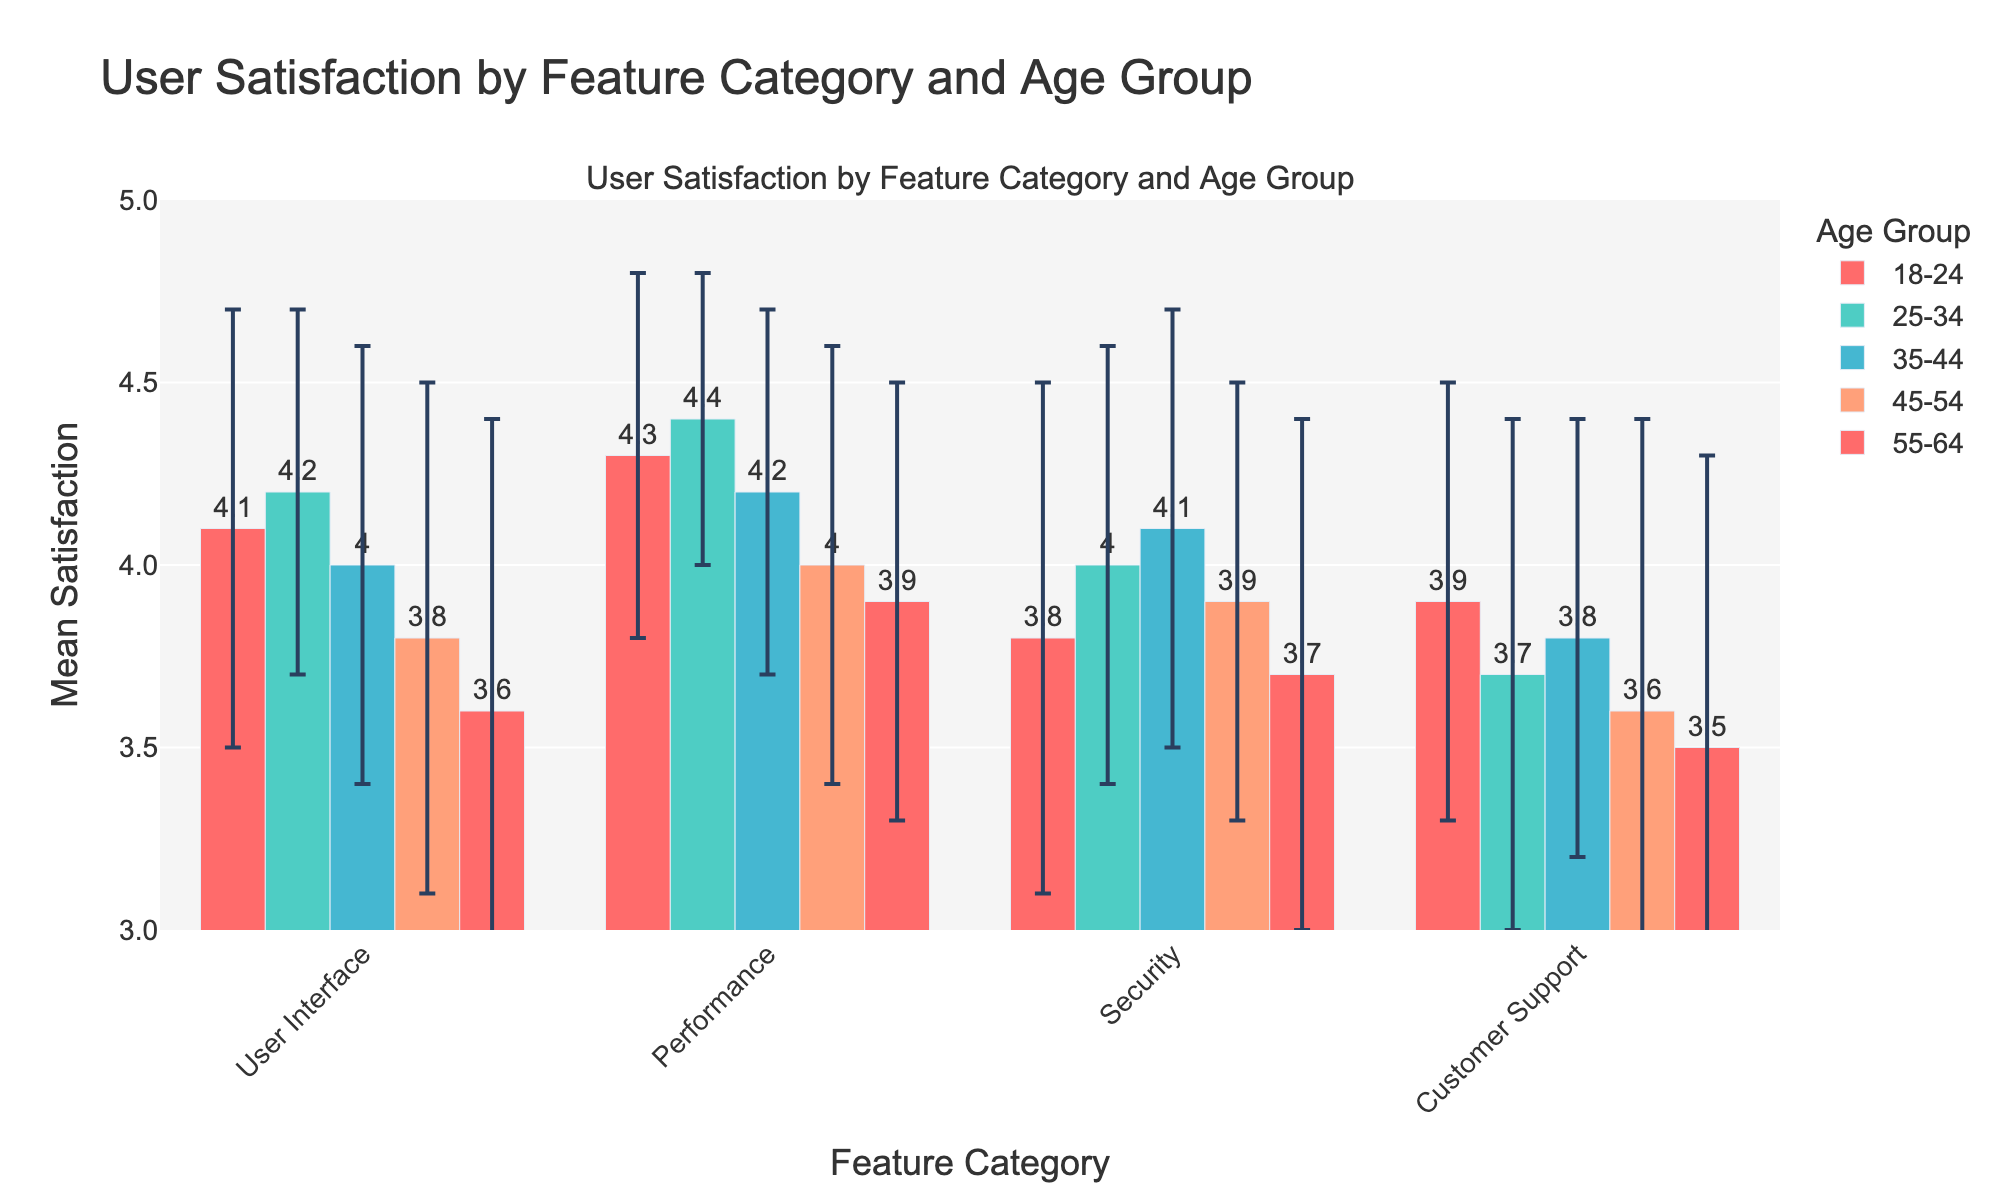What is the title of the figure? The title of the figure can be found at the top of the plot, which describes what the figure is about.
Answer: User Satisfaction by Feature Category and Age Group What feature category has the highest mean satisfaction rating for the age group 25-34? The bar representing the feature category with the highest value under the age group 25-34 will indicate the highest mean satisfaction rating.
Answer: Performance How does the mean satisfaction rating for Security in the age group 35-44 compare to the mean satisfaction rating for Security in the age group 18-24? Locate the bars representing the Security feature category for both age groups 18-24 and 35-44 and compare their heights.
Answer: Higher Which feature category has the largest variation in mean satisfaction ratings across all age groups? The feature category with the largest spread (or variation) among the mean satisfaction ratings across all age groups can be determined by observing the length of error bars.
Answer: Security What is the mean satisfaction rating for User Interface in the age group 55-64? Find the bar representing User Interface in the 55-64 age group and read off its value.
Answer: 3.6 What is the overall trend in mean satisfaction ratings for the Customer Support feature category as the age group increases from 18-24 to 55-64? By analyzing the heights of the bars for Customer Support across age groups 18-24, 25-34, 35-44, 45-54, and 55-64, the trend can be determined.
Answer: Decreasing What is the standard deviation for the age group 45-54 in the Performance feature category? Check the error bar length for the Performance bar within the 45-54 age group, which represents the standard deviation.
Answer: 0.6 Which age group exhibits the highest mean satisfaction rating for Performance, and what is that rating? To find which age group has the highest mean satisfaction for Performance, locate the corresponding bar for each age group and compare their heights.
Answer: Age group 25-34, rating 4.4 What is the range of mean satisfaction ratings for the Security feature category? Determine the lowest and highest mean satisfaction ratings for Security and calculate the difference. The lowest is 3.7 (age group 55-64) and the highest is 4.1 (age group 35-44).
Answer: 0.4 Are there any age groups where the standard deviation for all feature categories is the same? By checking the error bars for each feature category within every age group and comparing the lengths, it can be determined if any age group has uniform standard deviation.
Answer: No 